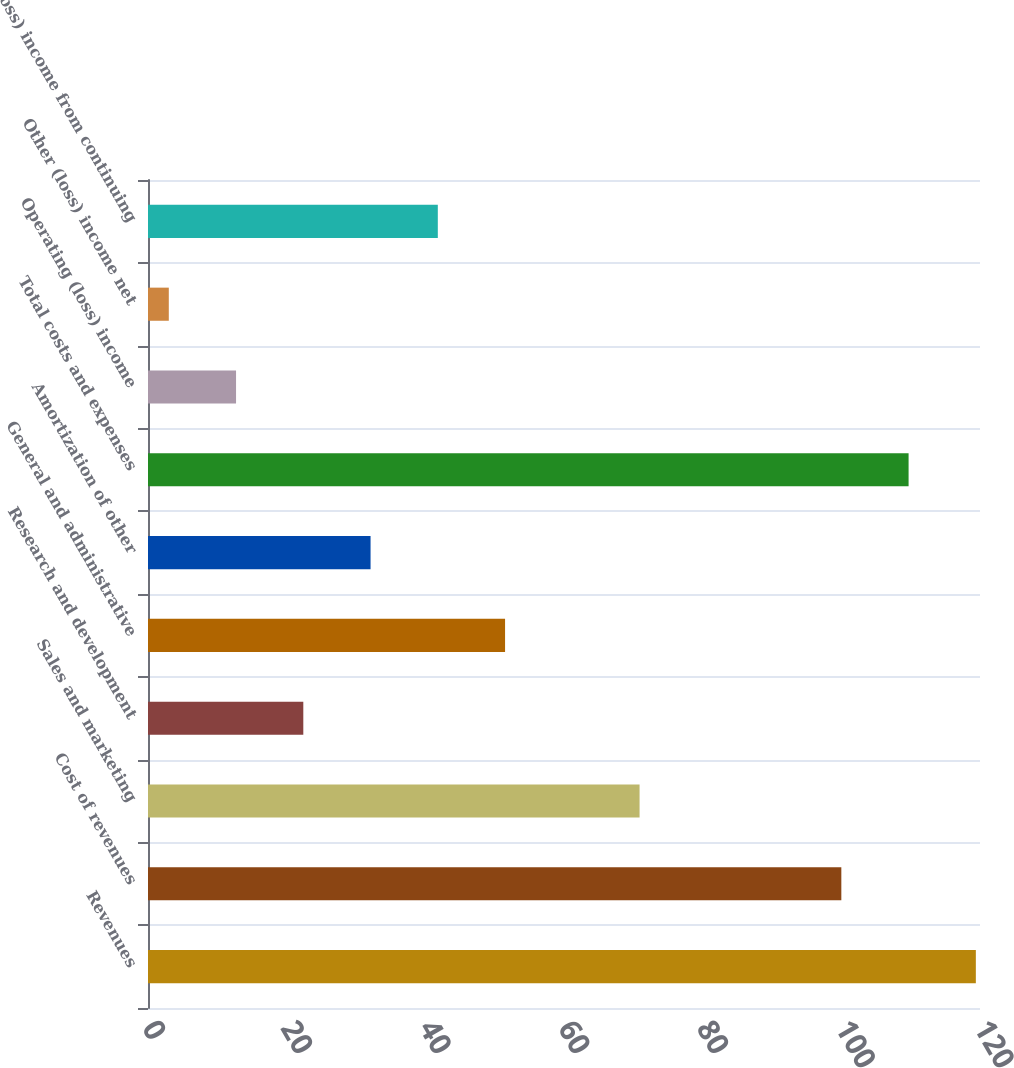<chart> <loc_0><loc_0><loc_500><loc_500><bar_chart><fcel>Revenues<fcel>Cost of revenues<fcel>Sales and marketing<fcel>Research and development<fcel>General and administrative<fcel>Amortization of other<fcel>Total costs and expenses<fcel>Operating (loss) income<fcel>Other (loss) income net<fcel>(Loss) income from continuing<nl><fcel>119.4<fcel>100<fcel>70.9<fcel>22.4<fcel>51.5<fcel>32.1<fcel>109.7<fcel>12.7<fcel>3<fcel>41.8<nl></chart> 